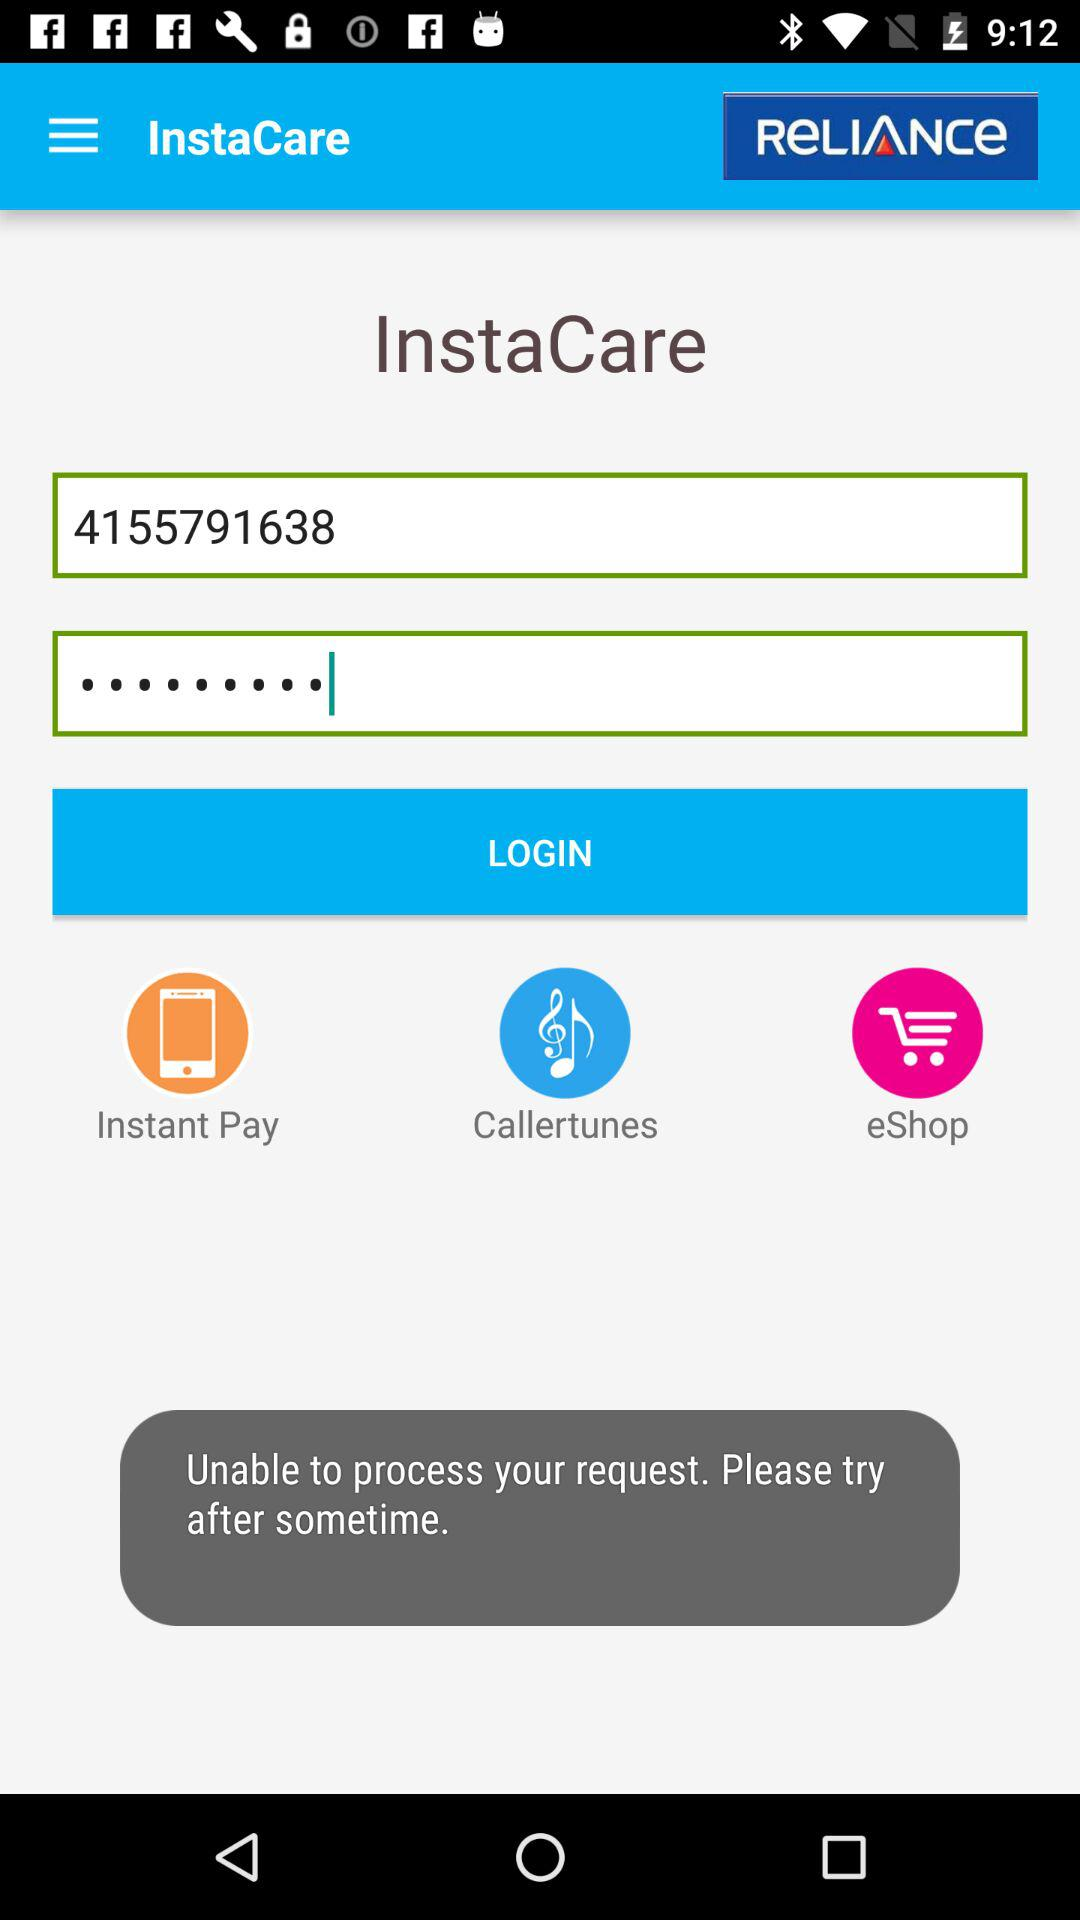What is the entered number? The entered number is 4155791638. 